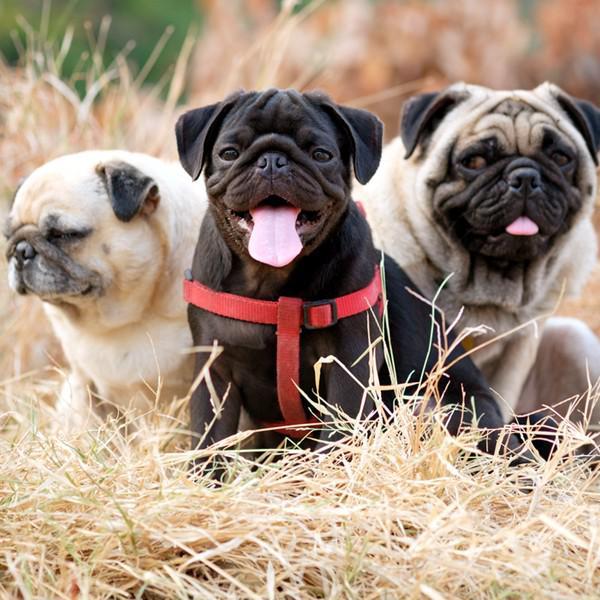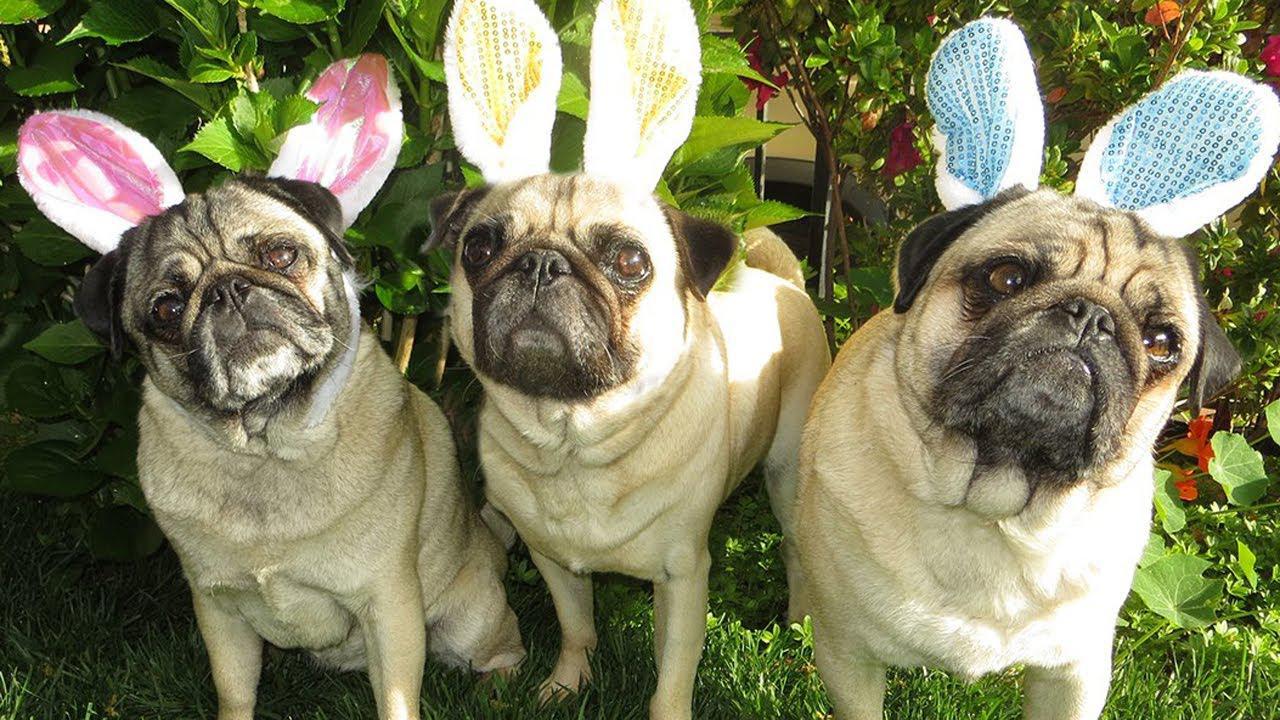The first image is the image on the left, the second image is the image on the right. Given the left and right images, does the statement "A total of five dogs are shown, and all dogs are wearing some type of attire other than an ordinary dog collar." hold true? Answer yes or no. No. The first image is the image on the left, the second image is the image on the right. Examine the images to the left and right. Is the description "All the dogs in the images are tan pugs." accurate? Answer yes or no. No. 